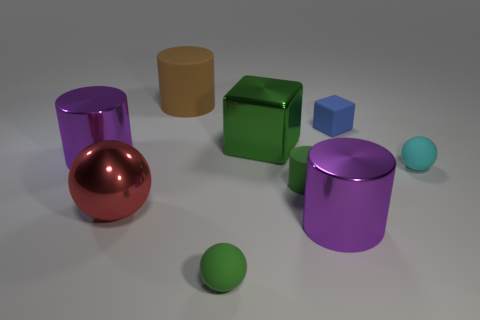Add 1 large green metallic blocks. How many objects exist? 10 Subtract all blocks. How many objects are left? 7 Subtract all large balls. Subtract all large purple shiny things. How many objects are left? 6 Add 3 big rubber objects. How many big rubber objects are left? 4 Add 1 large shiny things. How many large shiny things exist? 5 Subtract 0 gray cylinders. How many objects are left? 9 